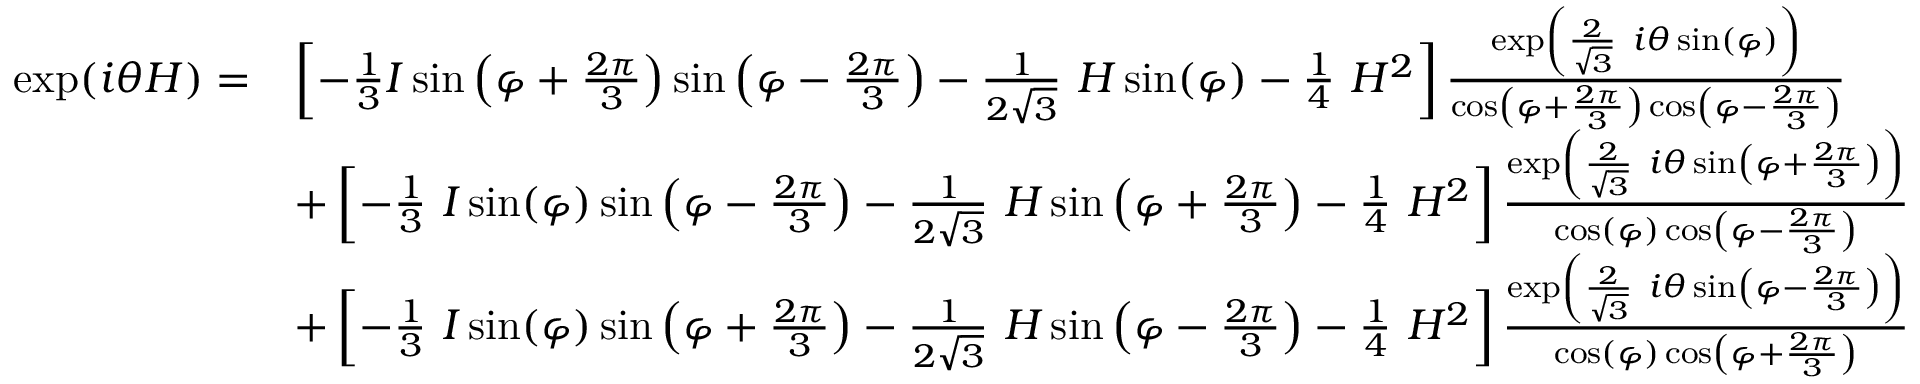Convert formula to latex. <formula><loc_0><loc_0><loc_500><loc_500>{ \begin{array} { r l } { \exp ( i \theta H ) = } & { \left [ - { \frac { 1 } { 3 } } I \sin \left ( \varphi + { \frac { 2 \pi } { 3 } } \right ) \sin \left ( \varphi - { \frac { 2 \pi } { 3 } } \right ) - { \frac { 1 } { 2 { \sqrt { 3 } } } } H \sin ( \varphi ) - { \frac { 1 } { 4 } } H ^ { 2 } \right ] { \frac { \exp \left ( { \frac { 2 } { \sqrt { 3 } } } i \theta \sin ( \varphi ) \right ) } { \cos \left ( \varphi + { \frac { 2 \pi } { 3 } } \right ) \cos \left ( \varphi - { \frac { 2 \pi } { 3 } } \right ) } } } \\ & { + \left [ - { \frac { 1 } { 3 } } I \sin ( \varphi ) \sin \left ( \varphi - { \frac { 2 \pi } { 3 } } \right ) - { \frac { 1 } { 2 { \sqrt { 3 } } } } H \sin \left ( \varphi + { \frac { 2 \pi } { 3 } } \right ) - { \frac { 1 } { 4 } } H ^ { 2 } \right ] { \frac { \exp \left ( { \frac { 2 } { \sqrt { 3 } } } i \theta \sin \left ( \varphi + { \frac { 2 \pi } { 3 } } \right ) \right ) } { \cos ( \varphi ) \cos \left ( \varphi - { \frac { 2 \pi } { 3 } } \right ) } } } \\ & { + \left [ - { \frac { 1 } { 3 } } I \sin ( \varphi ) \sin \left ( \varphi + { \frac { 2 \pi } { 3 } } \right ) - { \frac { 1 } { 2 { \sqrt { 3 } } } } H \sin \left ( \varphi - { \frac { 2 \pi } { 3 } } \right ) - { \frac { 1 } { 4 } } H ^ { 2 } \right ] { \frac { \exp \left ( { \frac { 2 } { \sqrt { 3 } } } i \theta \sin \left ( \varphi - { \frac { 2 \pi } { 3 } } \right ) \right ) } { \cos ( \varphi ) \cos \left ( \varphi + { \frac { 2 \pi } { 3 } } \right ) } } } \end{array} }</formula> 